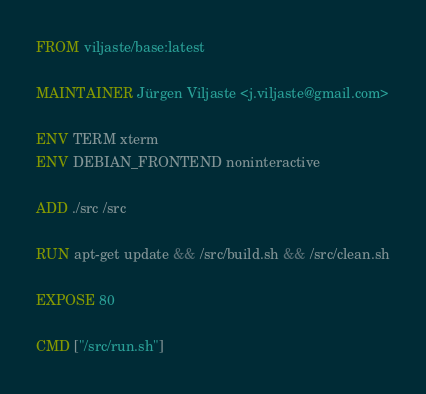<code> <loc_0><loc_0><loc_500><loc_500><_Dockerfile_>FROM viljaste/base:latest

MAINTAINER Jürgen Viljaste <j.viljaste@gmail.com>

ENV TERM xterm
ENV DEBIAN_FRONTEND noninteractive

ADD ./src /src

RUN apt-get update && /src/build.sh && /src/clean.sh

EXPOSE 80

CMD ["/src/run.sh"]
</code> 